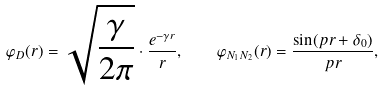Convert formula to latex. <formula><loc_0><loc_0><loc_500><loc_500>\varphi _ { D } ( r ) = \sqrt { \frac { \gamma } { 2 \pi } } \cdot \frac { e ^ { - \gamma r } } { r } , \quad \varphi _ { N _ { 1 } N _ { 2 } } ( r ) = \frac { \sin ( p r + \delta _ { 0 } ) } { p r } ,</formula> 